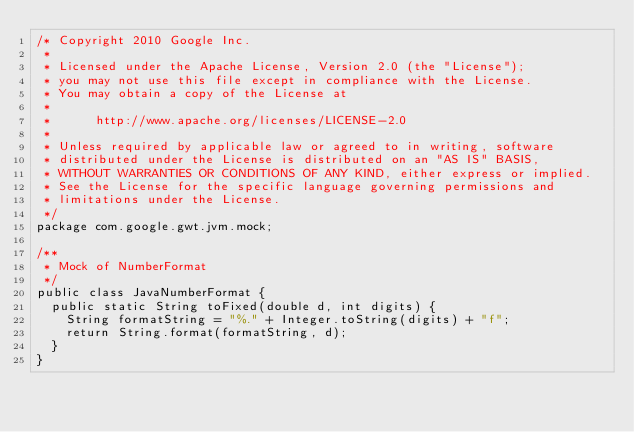<code> <loc_0><loc_0><loc_500><loc_500><_Java_>/* Copyright 2010 Google Inc.
 *
 * Licensed under the Apache License, Version 2.0 (the "License");
 * you may not use this file except in compliance with the License.
 * You may obtain a copy of the License at
 * 
 *      http://www.apache.org/licenses/LICENSE-2.0
 * 
 * Unless required by applicable law or agreed to in writing, software
 * distributed under the License is distributed on an "AS IS" BASIS,
 * WITHOUT WARRANTIES OR CONDITIONS OF ANY KIND, either express or implied.
 * See the License for the specific language governing permissions and
 * limitations under the License.
 */
package com.google.gwt.jvm.mock;

/**
 * Mock of NumberFormat
 */
public class JavaNumberFormat {
  public static String toFixed(double d, int digits) {
    String formatString = "%." + Integer.toString(digits) + "f";
    return String.format(formatString, d);
  }
}
</code> 